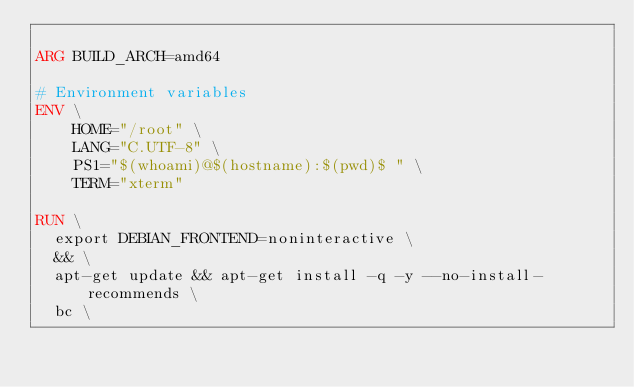Convert code to text. <code><loc_0><loc_0><loc_500><loc_500><_Dockerfile_>
ARG BUILD_ARCH=amd64

# Environment variables
ENV \
    HOME="/root" \
    LANG="C.UTF-8" \
    PS1="$(whoami)@$(hostname):$(pwd)$ " \
    TERM="xterm"

RUN \
  export DEBIAN_FRONTEND=noninteractive \
  && \
  apt-get update && apt-get install -q -y --no-install-recommends \
  bc \</code> 